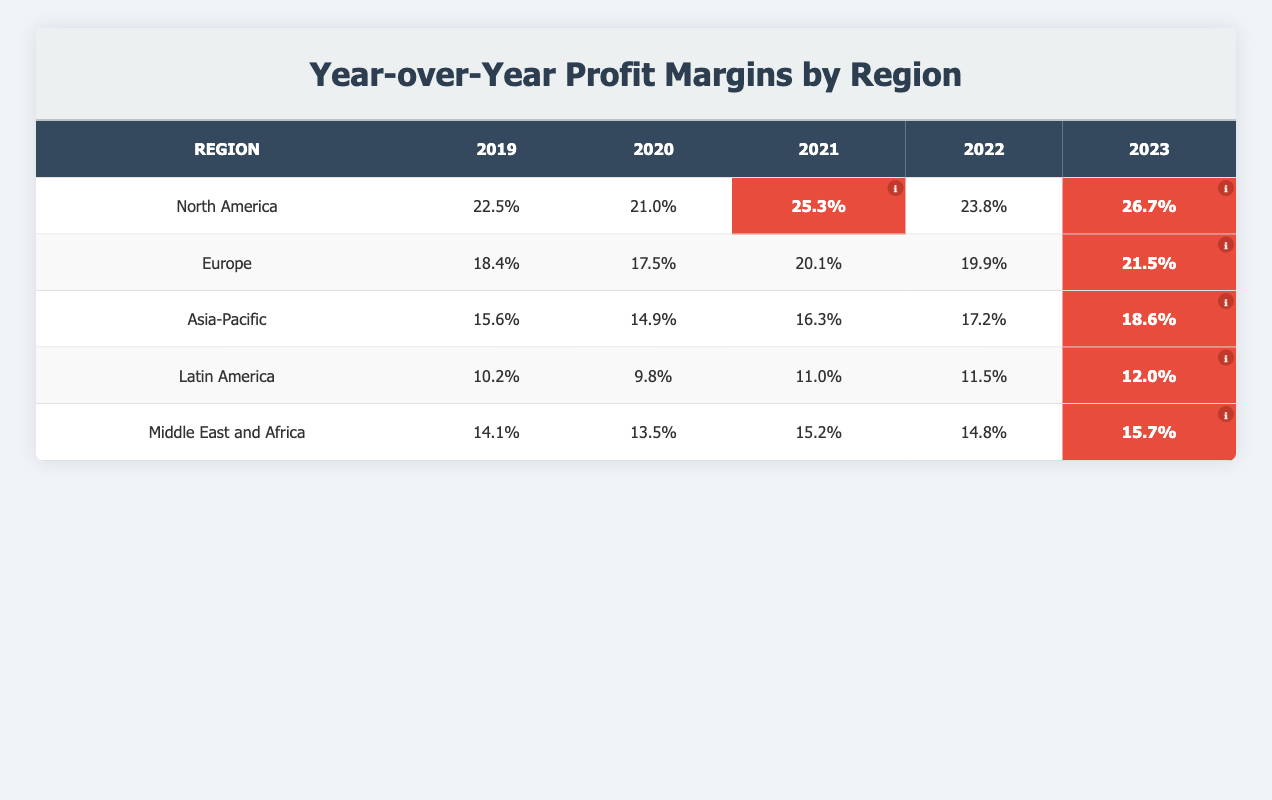What was the profit margin for North America in 2021? The table shows that the profit margin for North America in 2021 is marked as 25.3%.
Answer: 25.3% Which region had the highest profit margin in 2023? In the table, North America has the highest profit margin in 2023 with a value of 26.7%.
Answer: North America Did Europe’s profit margin increase or decrease from 2020 to 2021? In the table, Europe’s profit margin was 17.5% in 2020 and increased to 20.1% in 2021.
Answer: Increase What is the average profit margin for Asia-Pacific over the five years? To find the average, sum the profit margins: (15.6 + 14.9 + 16.3 + 17.2 + 18.6) = 82.6. Then divide by 5, 82.6/5 = 16.52.
Answer: 16.52 Which region had the least improvement in profit margin between 2019 and 2023? Calculate the change for each region from 2019 to 2023: North America (4.2), Europe (3.1), Asia-Pacific (3.0), Latin America (1.8), Middle East and Africa (1.6). Latin America had the least improvement of 1.8.
Answer: Latin America Is the statement true or false? "The profit margin for Latin America in 2023 was higher than in 2022." The profit margin for Latin America in 2022 was 11.5% and in 2023 it was 12.0%, so the statement is true.
Answer: True What was the trend in North America's profit margin from 2019 to 2023? Review the values: 22.5% (2019), 21.0% (2020), 25.3% (2021), 23.8% (2022), and 26.7% (2023). It declined from 2019 to 2020, then saw an increase thereafter.
Answer: Mixed (decrease then increase) By how much did the profit margin in the Middle East and Africa change from 2019 to 2023? The profit margin was 14.1% in 2019 and 15.7% in 2023, so the change is 15.7 - 14.1 = 1.6%.
Answer: 1.6% 